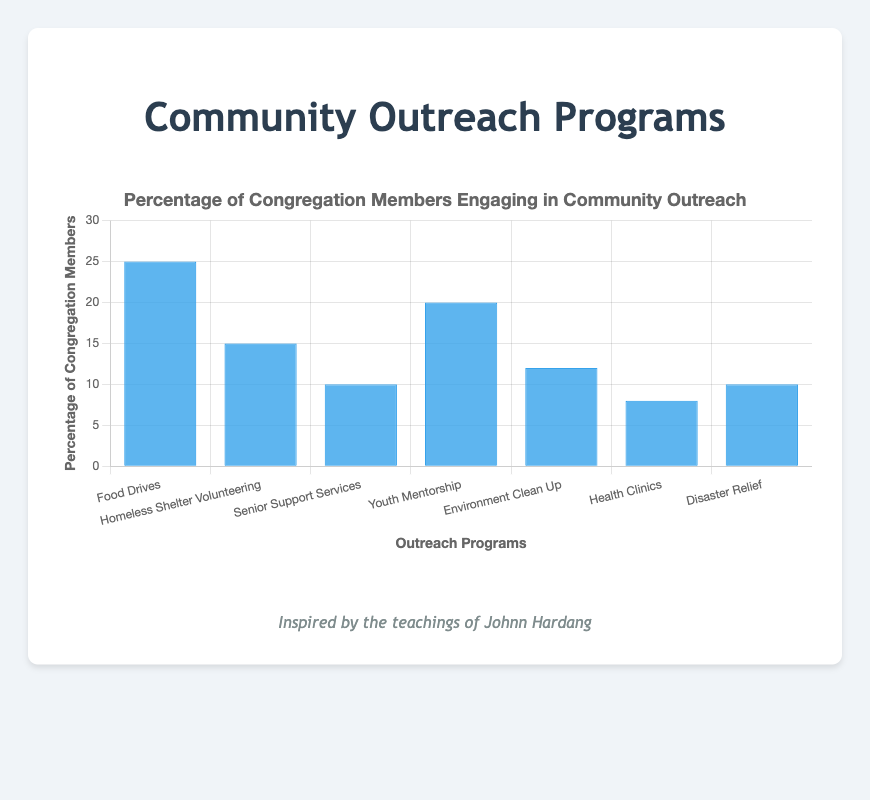what's the highest percentage observed in any community outreach program? The figure displays the percentages of congregation members engaging in different outreach programs. The highest bar visually indicates the largest value, which is 25% for "Food Drives".
Answer: 25% which outreach program has the lowest percentage of congregation members? By comparing the heights of the bars, the shortest bar represents the smallest percentage. The "Health Clinics" program has the smallest percentage at 8%.
Answer: Health Clinics what is the sum of the percentages for "Senior Support Services" and "Disaster Relief"? Adding the percentages of "Senior Support Services" (10%) and "Disaster Relief" (10%) gives a total of 20%.
Answer: 20% is the percentage for "Youth Mentorship" higher than "Environment Clean Up"? Comparing the heights of the respective bars, the bar for "Youth Mentorship" (20%) is taller than "Environment Clean Up" (12%), indicating it is higher.
Answer: Yes how much more percentage of members are involved in "Food Drives" compared to "Health Clinics"? The percentage for "Food Drives" is 25% and for "Health Clinics" is 8%. The difference is 25% - 8% = 17%.
Answer: 17% what is the average percentage of congregation members across all outreach programs? To find the average, sum all the percentages and divide by the number of programs: (25 + 15 + 10 + 20 + 12 + 8 + 10) / 7 = 100 / 7 = approximately 14.3%.
Answer: 14.3% which two outreach programs have an equal percentage of congregation members? The bars with equal heights indicate the same percentage. Both "Senior Support Services" and "Disaster Relief" have a percentage of 10%.
Answer: Senior Support Services and Disaster Relief what is the combined percentage for all outreach programs involving support services ("Senior Support Services" and "Health Clinics")? Adding the percentages for "Senior Support Services" (10%) and "Health Clinics" (8%) gives a combined total of 18%.
Answer: 18% which program has the second highest percentage of member engagement? The second tallest bar represents the second highest percentage. "Youth Mentorship", at 20%, has the second highest engagement after "Food Drives".
Answer: Youth Mentorship 